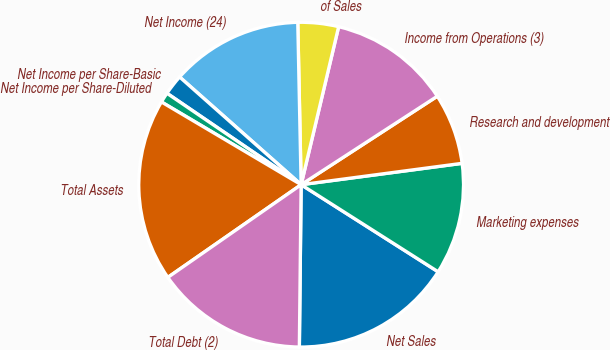Convert chart to OTSL. <chart><loc_0><loc_0><loc_500><loc_500><pie_chart><fcel>Net Sales<fcel>Marketing expenses<fcel>Research and development<fcel>Income from Operations (3)<fcel>of Sales<fcel>Net Income (24)<fcel>Net Income per Share-Basic<fcel>Net Income per Share-Diluted<fcel>Total Assets<fcel>Total Debt (2)<nl><fcel>16.16%<fcel>11.11%<fcel>7.07%<fcel>12.12%<fcel>4.04%<fcel>13.13%<fcel>2.02%<fcel>1.01%<fcel>18.18%<fcel>15.15%<nl></chart> 